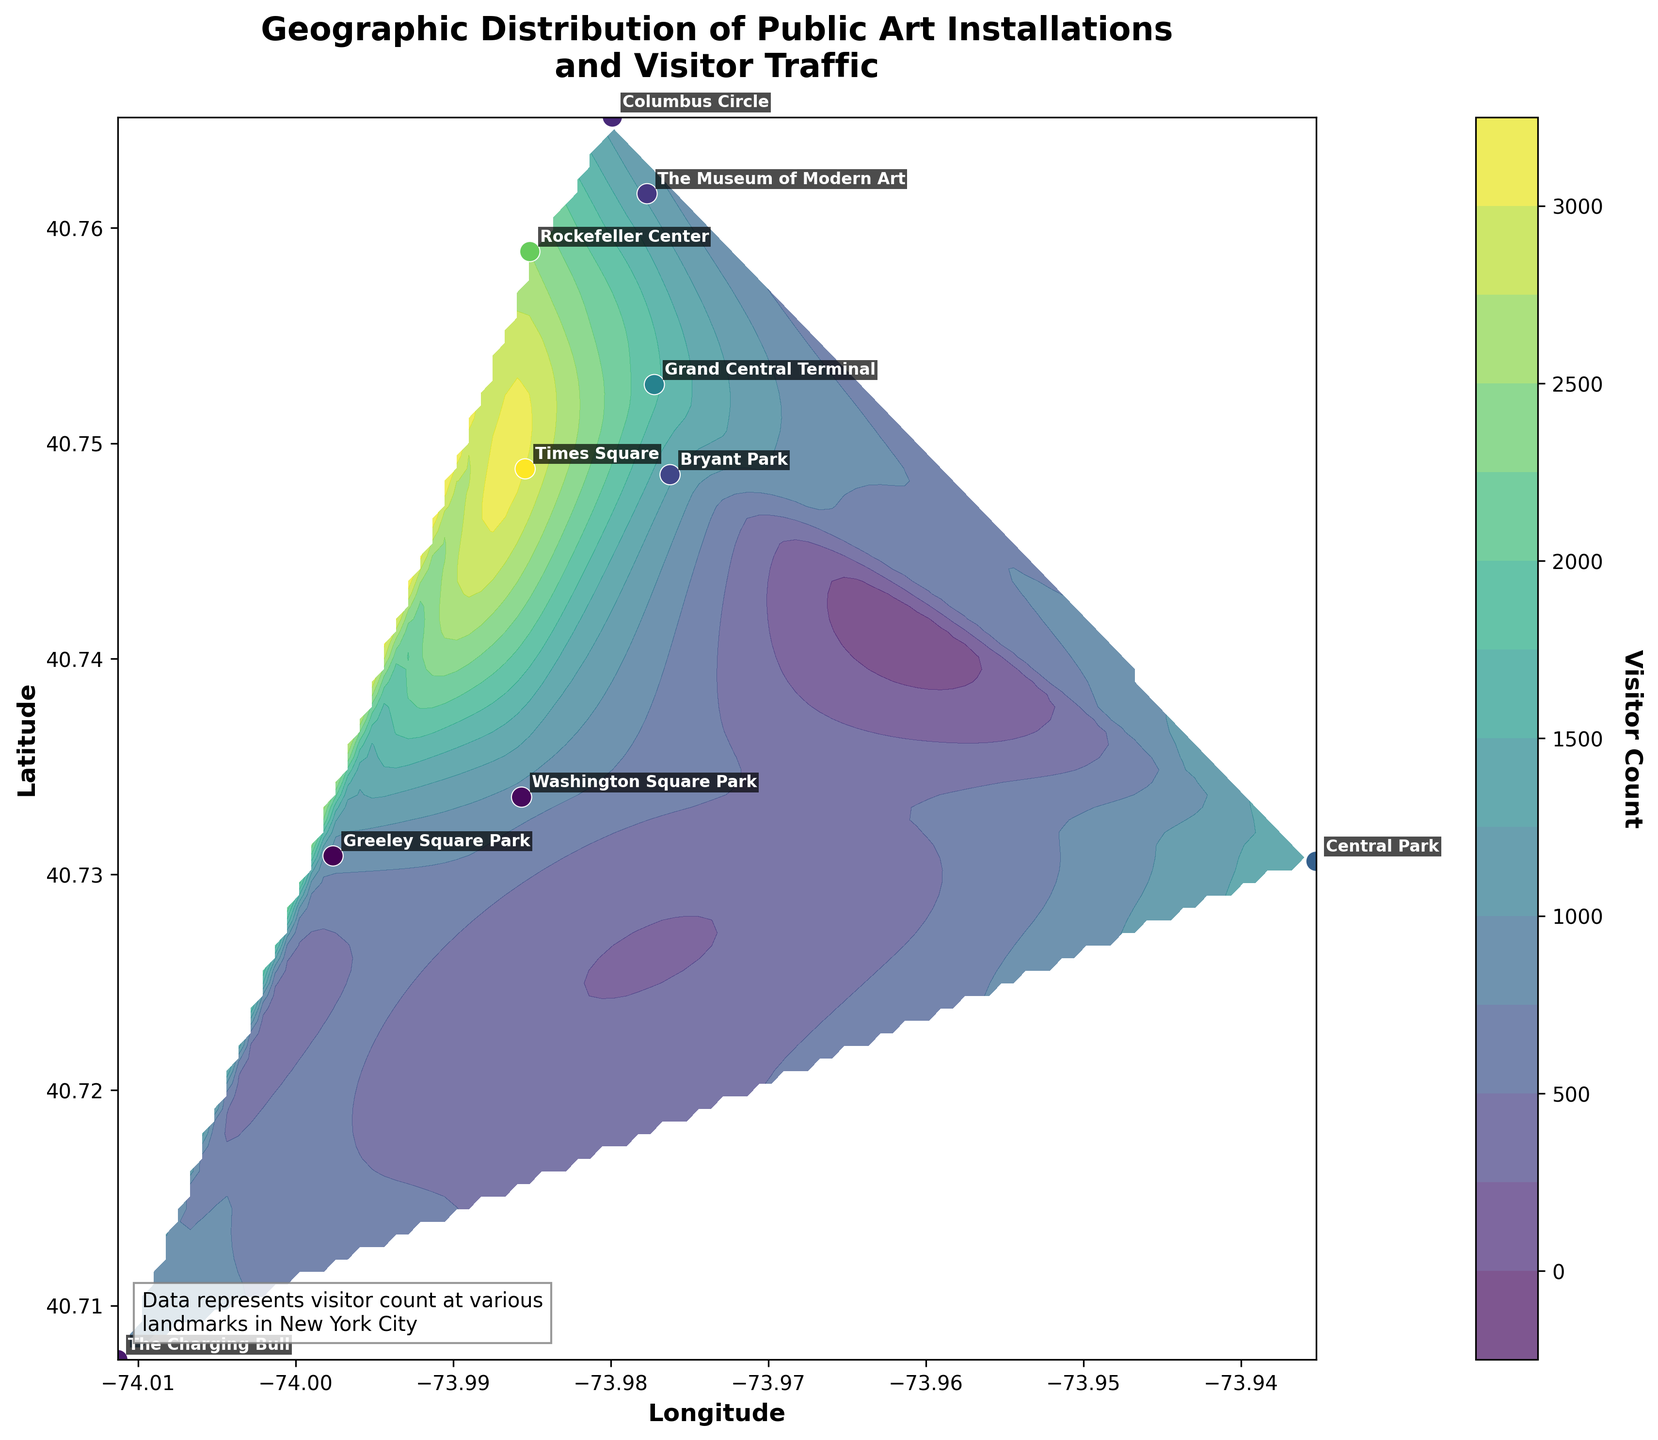What's the location with the highest visitor count? The location with the highest visitor count can be identified by looking for the highest point on the color scale or the largest number annotated. In this case, Times Square has the highest visitor count of 3000.
Answer: Times Square What's the color representing the highest visitor count? The highest visitor count is at Times Square, so we check the color of its corresponding location. It is the darkest shade on the colorbar, represented by the deepest tone in the 'viridis' colormap.
Answer: Darkest shade How many art installations are there in total? Each data point on the plot represents an art installation. Counting all annotations (names of locations) will give us the total number.
Answer: 10 Which two locations have the smallest difference in visitor count? To find this, we look for two locations with visitor counts that are closest to each other. Washington Square Park (900) and Greeley Square Park (850) have a difference of just 50 visitors.
Answer: Washington Square Park and Greeley Square Park What is the visitor count range in the plot? The highest visitor count is at Times Square (3000) and the lowest visitor count is at Greeley Square Park (850). So, the range is 3000 - 850.
Answer: 2150 Which location is nearest to the geographic center of the city? The geographic center can be approximated by visually identifying the middle of the plot's longitude and latitude range. Central Park appears to be closest to this center.
Answer: Central Park What is the average visitor count across all locations? Add all visitor counts and divide by the number of locations: (1500 + 3000 + 1200 + 900 + 2500 + 1000 + 1800 + 850 + 1300 + 1100) / 10. Calculate the sum (15150) and then the average.
Answer: 1515 How does the visitor count at Rockefeller Center compare to that of Bryant Park? Rockefeller Center has 2500 visitors, and Bryant Park has 1300 visitors. Rockefeller Center's count is greater than that of Bryant Park.
Answer: Higher What does the colorbar represent and how is it useful in interpreting the data? The colorbar represents the visitor count, with colors on the plot corresponding to different visitor numbers. It helps visually differentiate areas based on visitor density and identify high and low traffic locations quickly.
Answer: Visitor count density What is the visitor count spread around Times Square? Times Square has the highest count (3000). Looking at the surrounding contour levels, which are decreasing shades, tells us how quickly the visitor count decreases moving away from Times Square. The spread can be judged by how closely packed the contour levels are around this high.
Answer: High traffic concentration around immediate surroundings 